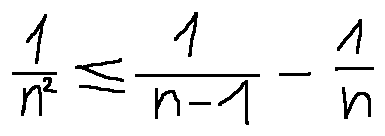Convert formula to latex. <formula><loc_0><loc_0><loc_500><loc_500>\frac { 1 } { n ^ { 2 } } \leq \frac { 1 } { n - 1 } - \frac { 1 } { n }</formula> 